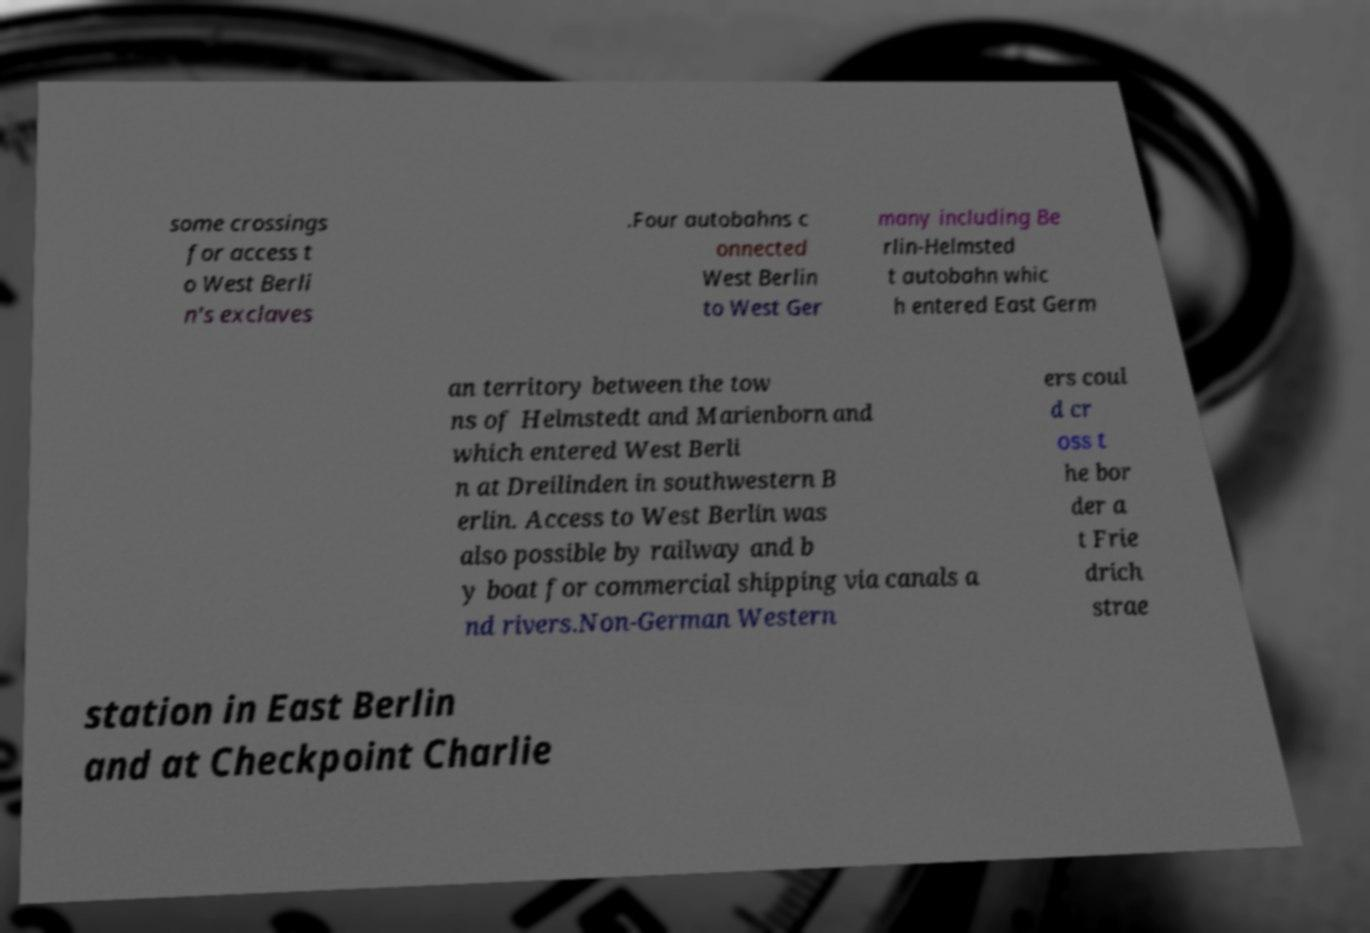Could you extract and type out the text from this image? some crossings for access t o West Berli n's exclaves .Four autobahns c onnected West Berlin to West Ger many including Be rlin-Helmsted t autobahn whic h entered East Germ an territory between the tow ns of Helmstedt and Marienborn and which entered West Berli n at Dreilinden in southwestern B erlin. Access to West Berlin was also possible by railway and b y boat for commercial shipping via canals a nd rivers.Non-German Western ers coul d cr oss t he bor der a t Frie drich strae station in East Berlin and at Checkpoint Charlie 